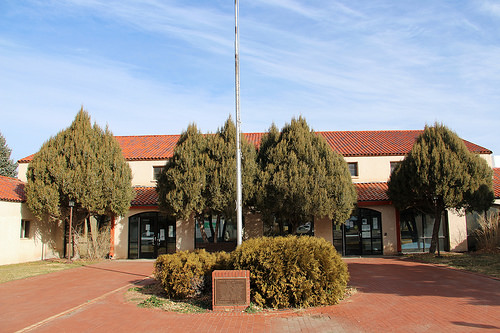<image>
Is the pole behind the tree? No. The pole is not behind the tree. From this viewpoint, the pole appears to be positioned elsewhere in the scene. 